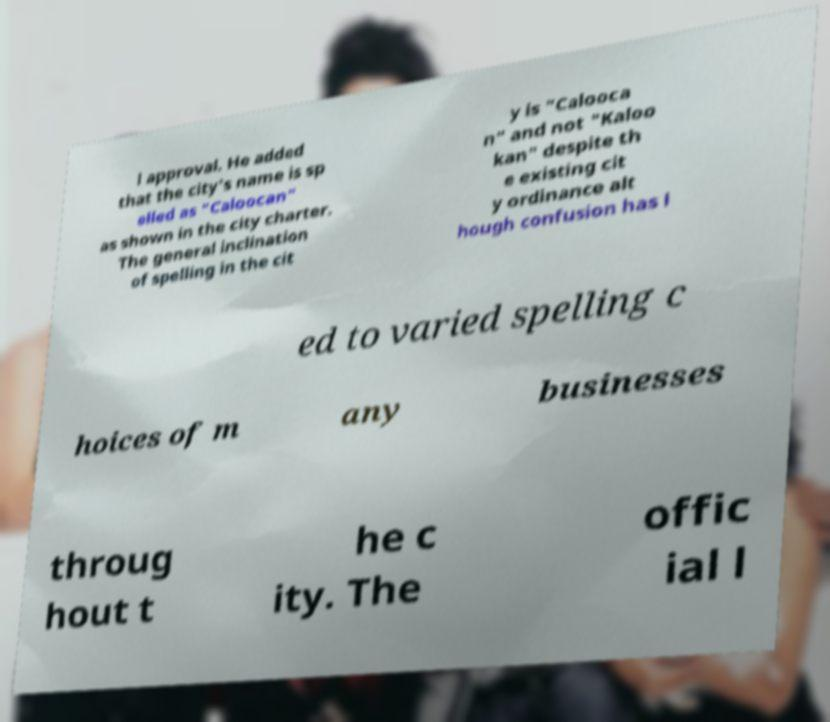Please identify and transcribe the text found in this image. l approval. He added that the city's name is sp elled as "Caloocan" as shown in the city charter. The general inclination of spelling in the cit y is "Calooca n" and not "Kaloo kan" despite th e existing cit y ordinance alt hough confusion has l ed to varied spelling c hoices of m any businesses throug hout t he c ity. The offic ial l 